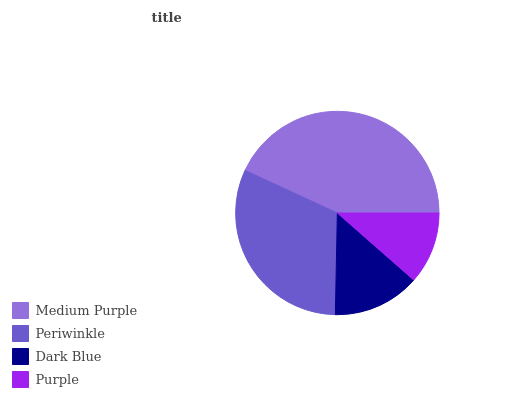Is Purple the minimum?
Answer yes or no. Yes. Is Medium Purple the maximum?
Answer yes or no. Yes. Is Periwinkle the minimum?
Answer yes or no. No. Is Periwinkle the maximum?
Answer yes or no. No. Is Medium Purple greater than Periwinkle?
Answer yes or no. Yes. Is Periwinkle less than Medium Purple?
Answer yes or no. Yes. Is Periwinkle greater than Medium Purple?
Answer yes or no. No. Is Medium Purple less than Periwinkle?
Answer yes or no. No. Is Periwinkle the high median?
Answer yes or no. Yes. Is Dark Blue the low median?
Answer yes or no. Yes. Is Medium Purple the high median?
Answer yes or no. No. Is Periwinkle the low median?
Answer yes or no. No. 